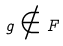Convert formula to latex. <formula><loc_0><loc_0><loc_500><loc_500>g \notin F</formula> 